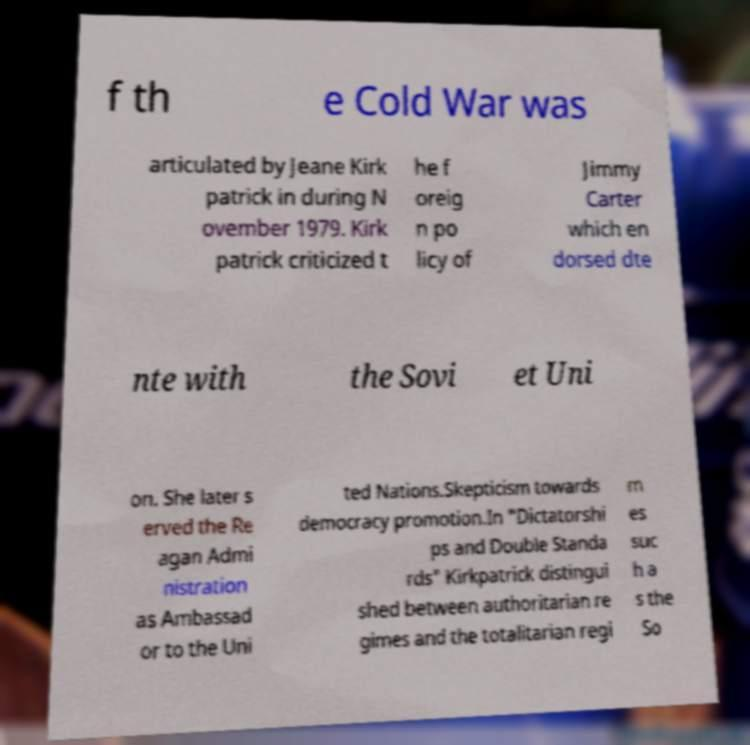Please identify and transcribe the text found in this image. f th e Cold War was articulated by Jeane Kirk patrick in during N ovember 1979. Kirk patrick criticized t he f oreig n po licy of Jimmy Carter which en dorsed dte nte with the Sovi et Uni on. She later s erved the Re agan Admi nistration as Ambassad or to the Uni ted Nations.Skepticism towards democracy promotion.In "Dictatorshi ps and Double Standa rds" Kirkpatrick distingui shed between authoritarian re gimes and the totalitarian regi m es suc h a s the So 